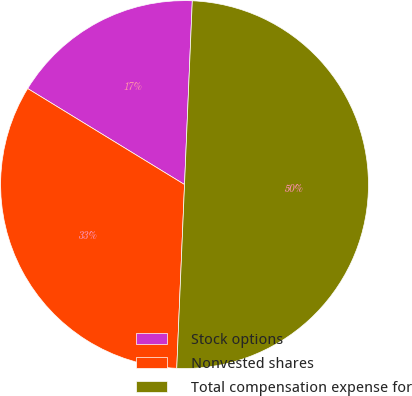<chart> <loc_0><loc_0><loc_500><loc_500><pie_chart><fcel>Stock options<fcel>Nonvested shares<fcel>Total compensation expense for<nl><fcel>16.93%<fcel>33.07%<fcel>50.0%<nl></chart> 